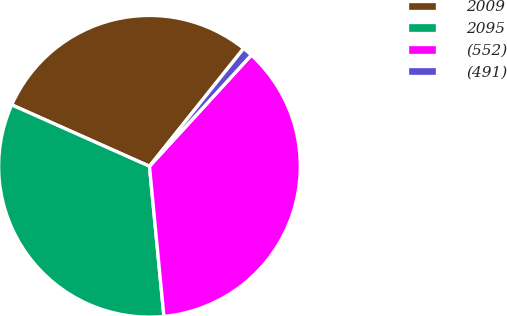<chart> <loc_0><loc_0><loc_500><loc_500><pie_chart><fcel>2009<fcel>2095<fcel>(552)<fcel>(491)<nl><fcel>29.06%<fcel>33.2%<fcel>36.67%<fcel>1.07%<nl></chart> 